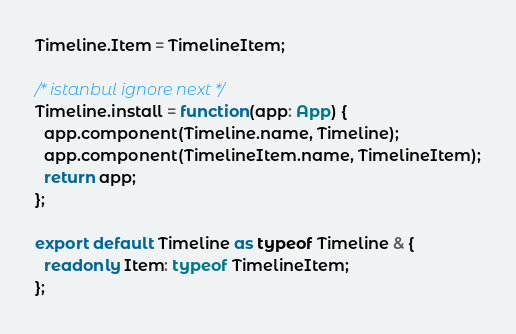Convert code to text. <code><loc_0><loc_0><loc_500><loc_500><_TypeScript_>Timeline.Item = TimelineItem;

/* istanbul ignore next */
Timeline.install = function(app: App) {
  app.component(Timeline.name, Timeline);
  app.component(TimelineItem.name, TimelineItem);
  return app;
};

export default Timeline as typeof Timeline & {
  readonly Item: typeof TimelineItem;
};
</code> 